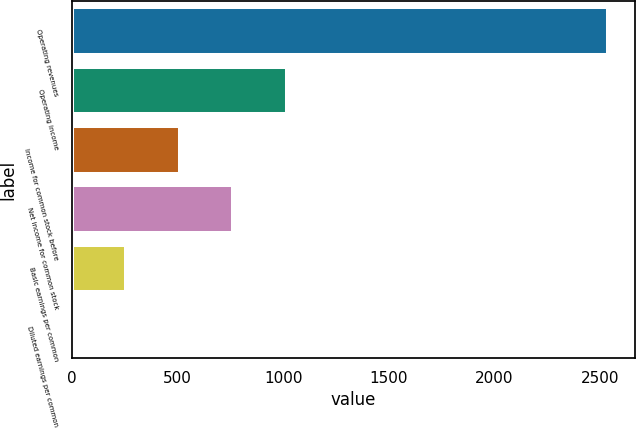Convert chart. <chart><loc_0><loc_0><loc_500><loc_500><bar_chart><fcel>Operating revenues<fcel>Operating income<fcel>Income for common stock before<fcel>Net income for common stock<fcel>Basic earnings per common<fcel>Diluted earnings per common<nl><fcel>2539<fcel>1016.41<fcel>508.87<fcel>762.64<fcel>255.1<fcel>1.33<nl></chart> 